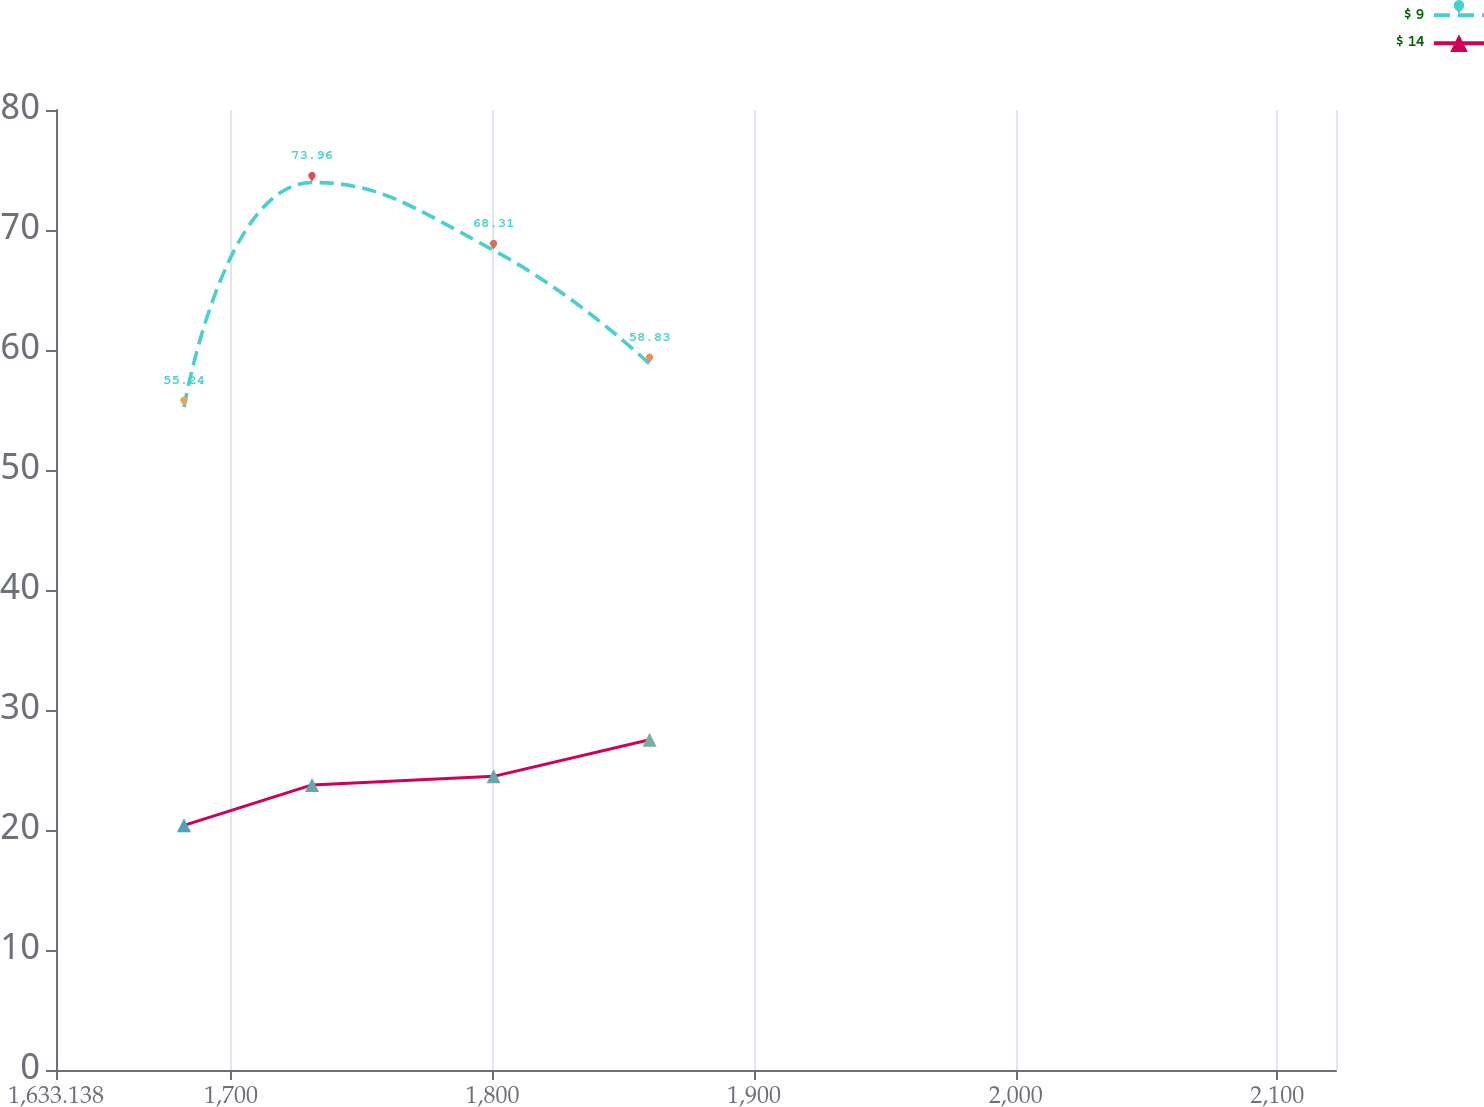<chart> <loc_0><loc_0><loc_500><loc_500><line_chart><ecel><fcel>$ 9<fcel>$ 14<nl><fcel>1682.07<fcel>55.24<fcel>20.39<nl><fcel>1731<fcel>73.96<fcel>23.76<nl><fcel>1800.42<fcel>68.31<fcel>24.47<nl><fcel>1860.05<fcel>58.83<fcel>27.52<nl><fcel>2171.39<fcel>65.87<fcel>22.17<nl></chart> 